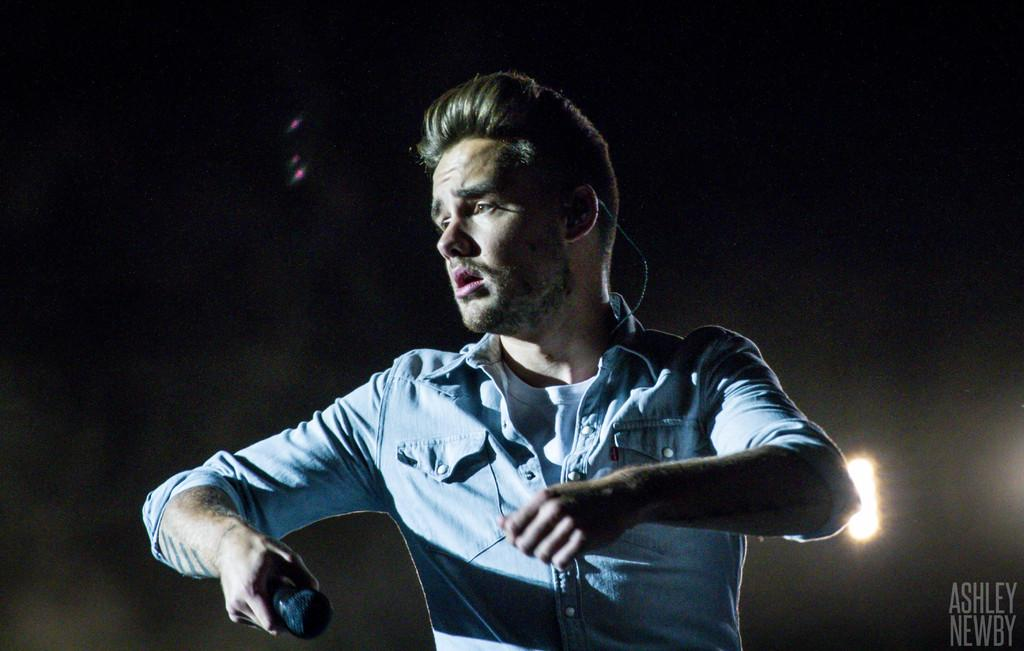What is the man in the image holding? The man is holding a mic. What is the man wearing in the image? The man is wearing a blue shirt. What type of hope can be seen in the man's eyes in the image? There is no reference to hope or the man's eyes in the image, so it is not possible to determine what type of hope might be present. 